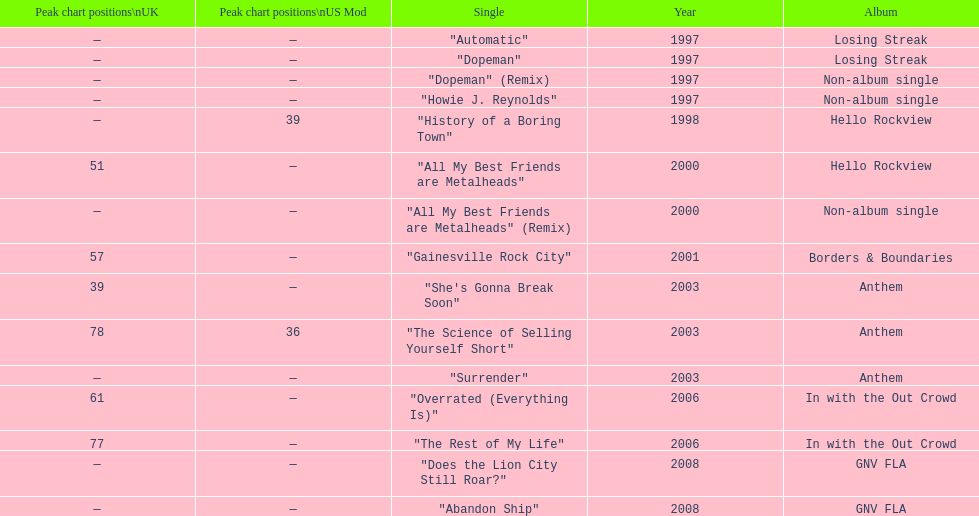Which song came out first? dopeman or surrender. Dopeman. 